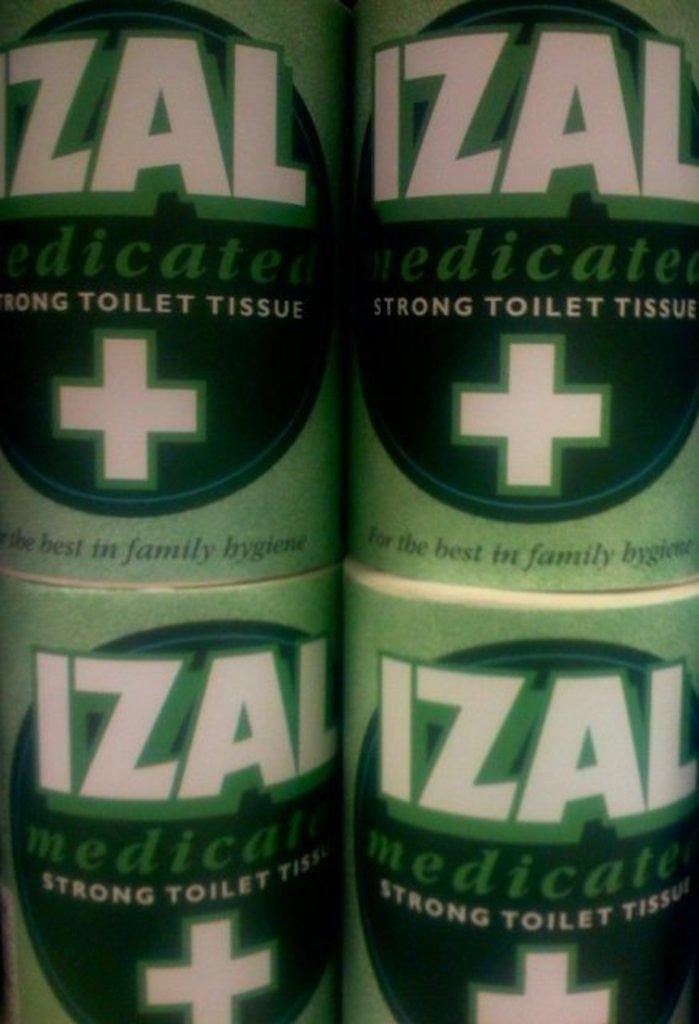<image>
Create a compact narrative representing the image presented. Four rolls of Izal toilet tissue with a white plus sign on the label 